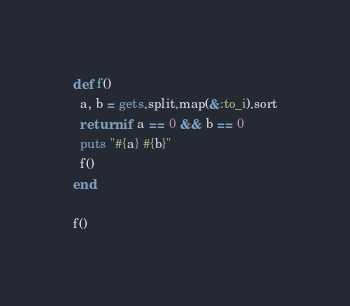<code> <loc_0><loc_0><loc_500><loc_500><_Ruby_>def f()
  a, b = gets.split.map(&:to_i).sort
  return if a == 0 && b == 0
  puts "#{a} #{b}"
  f()
end

f()
</code> 